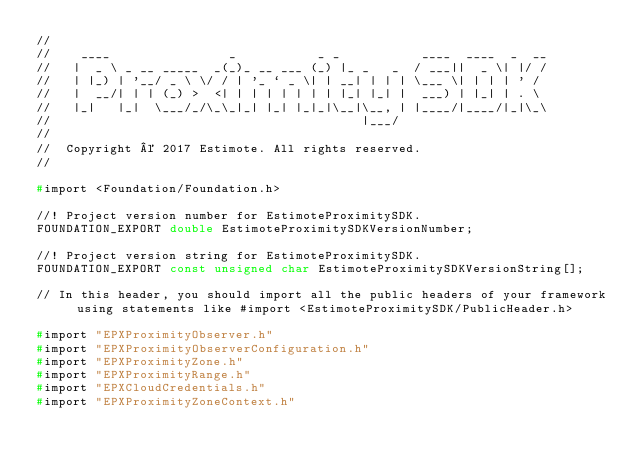<code> <loc_0><loc_0><loc_500><loc_500><_C_>//
//    ____                _           _ _           ____  ____  _  __
//   |  _ \ _ __ _____  _(_)_ __ ___ (_) |_ _   _  / ___||  _ \| |/ /
//   | |_) | '__/ _ \ \/ / | '_ ` _ \| | __| | | | \___ \| | | | ' /
//   |  __/| | | (_) >  <| | | | | | | | |_| |_| |  ___) | |_| | . \
//   |_|   |_|  \___/_/\_\_|_| |_| |_|_|\__|\__, | |____/|____/|_|\_\
//                                          |___/
//
//  Copyright © 2017 Estimote. All rights reserved.
//

#import <Foundation/Foundation.h>

//! Project version number for EstimoteProximitySDK.
FOUNDATION_EXPORT double EstimoteProximitySDKVersionNumber;

//! Project version string for EstimoteProximitySDK.
FOUNDATION_EXPORT const unsigned char EstimoteProximitySDKVersionString[];

// In this header, you should import all the public headers of your framework using statements like #import <EstimoteProximitySDK/PublicHeader.h>

#import "EPXProximityObserver.h"
#import "EPXProximityObserverConfiguration.h"
#import "EPXProximityZone.h"
#import "EPXProximityRange.h"
#import "EPXCloudCredentials.h"
#import "EPXProximityZoneContext.h"
</code> 